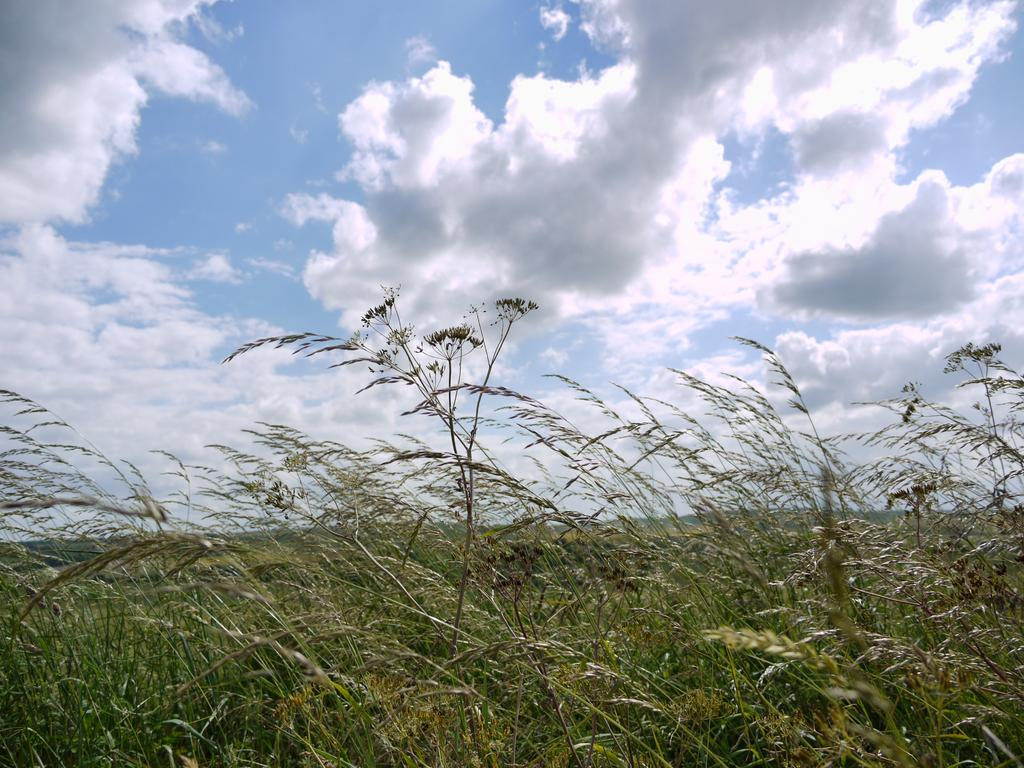What type of living organisms can be seen in the image? Plants can be seen in the image. Where are the plants located in relation to the image? The plants are in the foreground of the image. What can be seen in the background of the image? The sky is visible in the background of the image. How would you describe the sky in the image? The sky is cloudy in the image. What type of advice can be seen written on the frame of the image? There is no frame or advice present in the image; it features plants in the foreground and a cloudy sky in the background. 